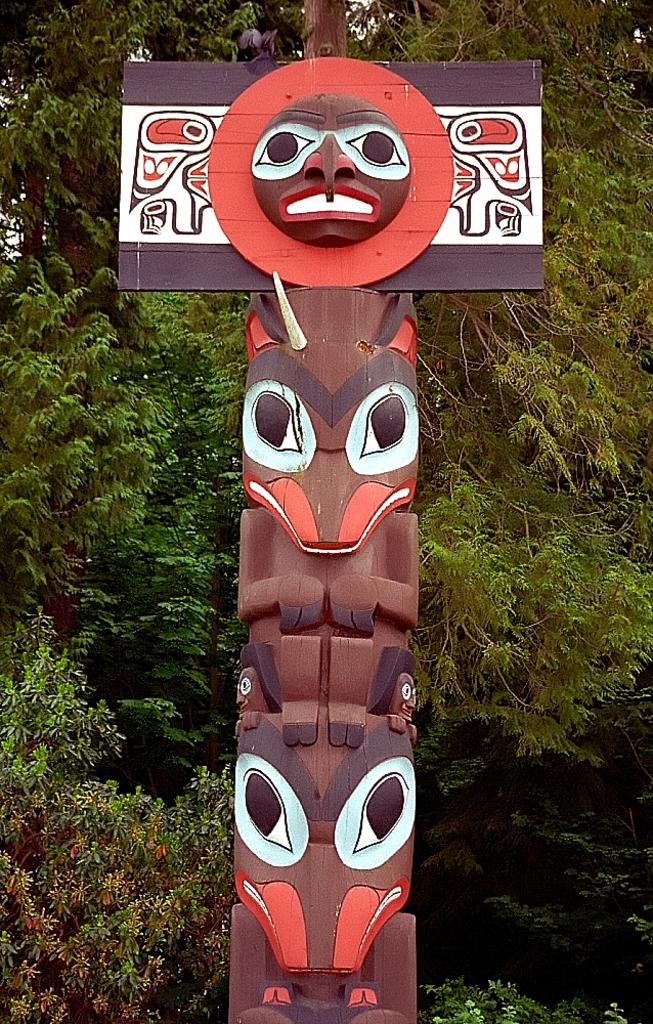What is the main subject in the middle of the image? There is a statue in the middle of the image. What can be seen in the background of the image? There are trees visible in the background of the image. What type of glue is being used to say good-bye to the statue in the image? There is no glue or any indication of saying good-bye to the statue in the image. What type of lip can be seen on the statue in the image? The statue does not have any lips, as it is an inanimate object. 